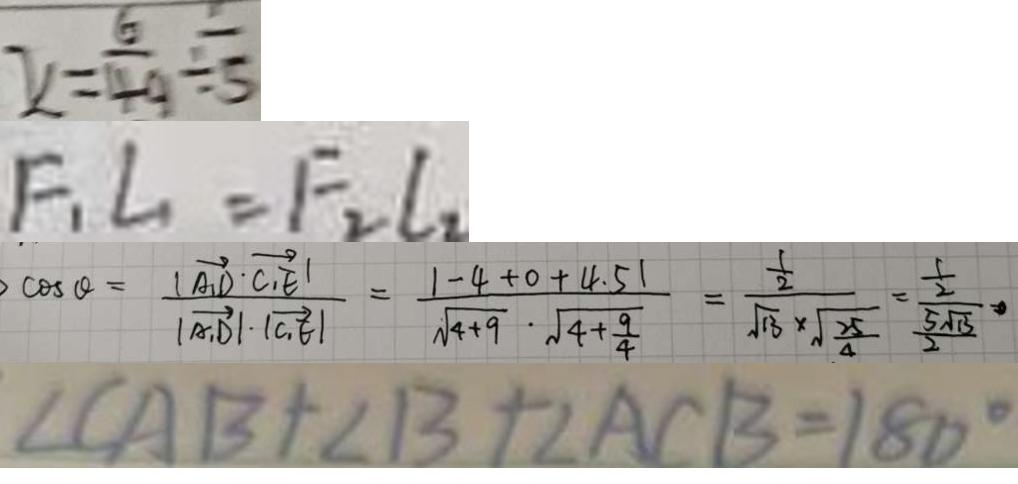<formula> <loc_0><loc_0><loc_500><loc_500>x = \frac { 6 } { 4 9 } \div \frac { 1 } { 5 } 
 F _ { 1 } L _ { 1 } = F _ { 2 } l _ { 2 } 
 \cos \theta = \frac { \vert \overrightarrow { A _ { 1 } D } \cdot \overrightarrow { C _ { 1 } E } \vert } { \vert \overrightarrow { A _ { 1 } D } \vert \cdot \vert \overrightarrow { C _ { 1 } E } \vert } = \frac { \vert - 4 + 0 + 4 . 5 \vert } { \sqrt { 4 + 9 } \cdot \sqrt { 4 + \frac { 9 } { 4 } } } = \frac { \frac { 1 } { 2 } } { \sqrt { 1 3 } \times \sqrt { \frac { 2 5 } { 4 } } } = \frac { \frac { 1 } { 2 } } { \frac { 5 \sqrt { 1 3 } } { 2 } } 
 \angle C A B + \angle B + \angle A C B = 1 8 0 ^ { \circ }</formula> 